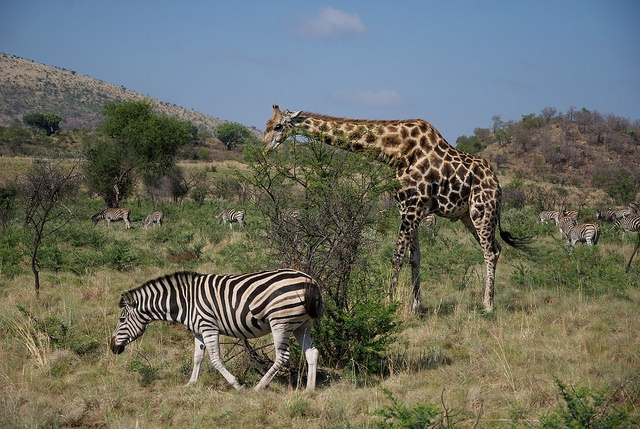Describe the objects in this image and their specific colors. I can see giraffe in gray, black, and maroon tones, zebra in gray, black, darkgray, and lightgray tones, zebra in gray, darkgray, darkgreen, and black tones, zebra in gray, black, and darkgray tones, and zebra in gray, darkgray, darkgreen, and black tones in this image. 